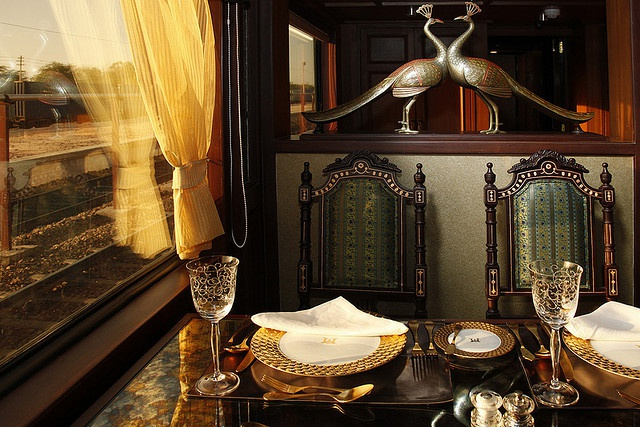Describe the objects in this image and their specific colors. I can see dining table in tan, black, maroon, and brown tones, chair in tan, black, maroon, olive, and gray tones, chair in tan, black, olive, gray, and maroon tones, wine glass in tan, black, olive, and maroon tones, and wine glass in tan, black, maroon, olive, and brown tones in this image. 